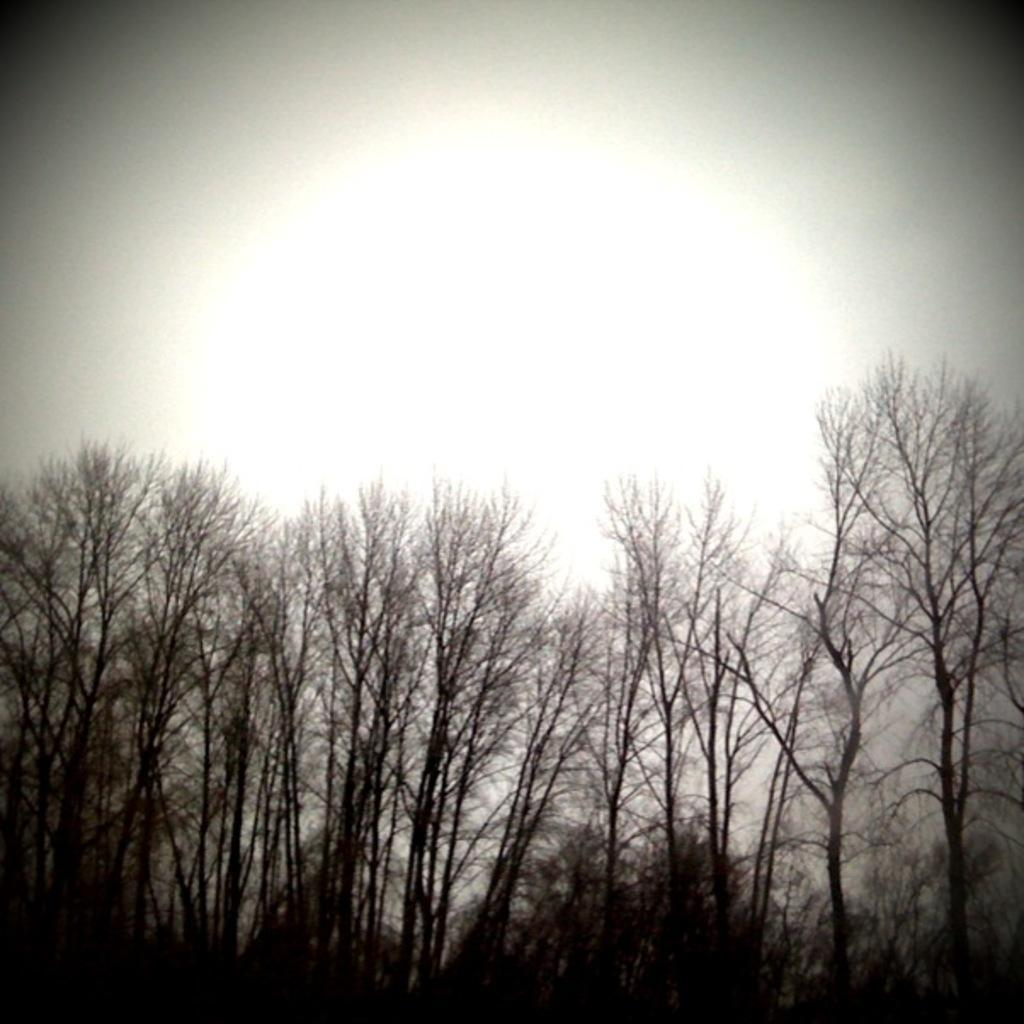What type of vegetation can be seen in the image? There are trees in the image. What part of the natural environment is visible in the image? The sky is visible in the background of the image. Can you hear the mice running around in the image? There are no mice present in the image, so it is not possible to hear them. 